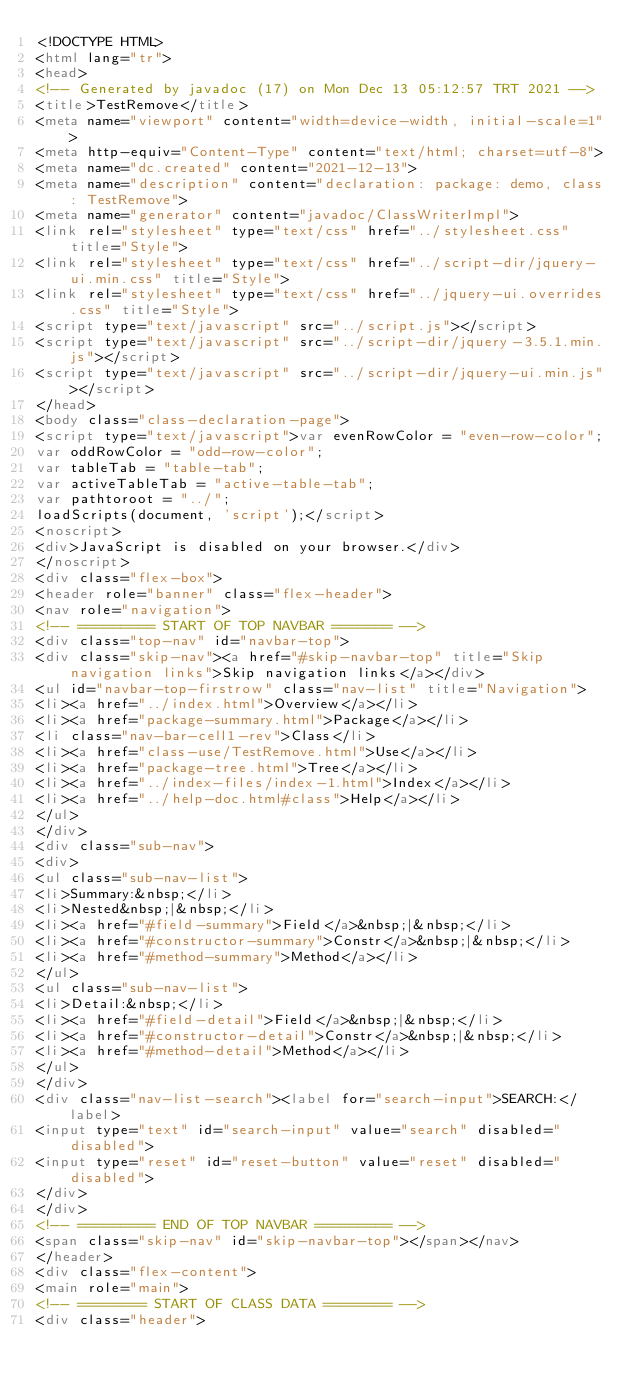<code> <loc_0><loc_0><loc_500><loc_500><_HTML_><!DOCTYPE HTML>
<html lang="tr">
<head>
<!-- Generated by javadoc (17) on Mon Dec 13 05:12:57 TRT 2021 -->
<title>TestRemove</title>
<meta name="viewport" content="width=device-width, initial-scale=1">
<meta http-equiv="Content-Type" content="text/html; charset=utf-8">
<meta name="dc.created" content="2021-12-13">
<meta name="description" content="declaration: package: demo, class: TestRemove">
<meta name="generator" content="javadoc/ClassWriterImpl">
<link rel="stylesheet" type="text/css" href="../stylesheet.css" title="Style">
<link rel="stylesheet" type="text/css" href="../script-dir/jquery-ui.min.css" title="Style">
<link rel="stylesheet" type="text/css" href="../jquery-ui.overrides.css" title="Style">
<script type="text/javascript" src="../script.js"></script>
<script type="text/javascript" src="../script-dir/jquery-3.5.1.min.js"></script>
<script type="text/javascript" src="../script-dir/jquery-ui.min.js"></script>
</head>
<body class="class-declaration-page">
<script type="text/javascript">var evenRowColor = "even-row-color";
var oddRowColor = "odd-row-color";
var tableTab = "table-tab";
var activeTableTab = "active-table-tab";
var pathtoroot = "../";
loadScripts(document, 'script');</script>
<noscript>
<div>JavaScript is disabled on your browser.</div>
</noscript>
<div class="flex-box">
<header role="banner" class="flex-header">
<nav role="navigation">
<!-- ========= START OF TOP NAVBAR ======= -->
<div class="top-nav" id="navbar-top">
<div class="skip-nav"><a href="#skip-navbar-top" title="Skip navigation links">Skip navigation links</a></div>
<ul id="navbar-top-firstrow" class="nav-list" title="Navigation">
<li><a href="../index.html">Overview</a></li>
<li><a href="package-summary.html">Package</a></li>
<li class="nav-bar-cell1-rev">Class</li>
<li><a href="class-use/TestRemove.html">Use</a></li>
<li><a href="package-tree.html">Tree</a></li>
<li><a href="../index-files/index-1.html">Index</a></li>
<li><a href="../help-doc.html#class">Help</a></li>
</ul>
</div>
<div class="sub-nav">
<div>
<ul class="sub-nav-list">
<li>Summary:&nbsp;</li>
<li>Nested&nbsp;|&nbsp;</li>
<li><a href="#field-summary">Field</a>&nbsp;|&nbsp;</li>
<li><a href="#constructor-summary">Constr</a>&nbsp;|&nbsp;</li>
<li><a href="#method-summary">Method</a></li>
</ul>
<ul class="sub-nav-list">
<li>Detail:&nbsp;</li>
<li><a href="#field-detail">Field</a>&nbsp;|&nbsp;</li>
<li><a href="#constructor-detail">Constr</a>&nbsp;|&nbsp;</li>
<li><a href="#method-detail">Method</a></li>
</ul>
</div>
<div class="nav-list-search"><label for="search-input">SEARCH:</label>
<input type="text" id="search-input" value="search" disabled="disabled">
<input type="reset" id="reset-button" value="reset" disabled="disabled">
</div>
</div>
<!-- ========= END OF TOP NAVBAR ========= -->
<span class="skip-nav" id="skip-navbar-top"></span></nav>
</header>
<div class="flex-content">
<main role="main">
<!-- ======== START OF CLASS DATA ======== -->
<div class="header"></code> 